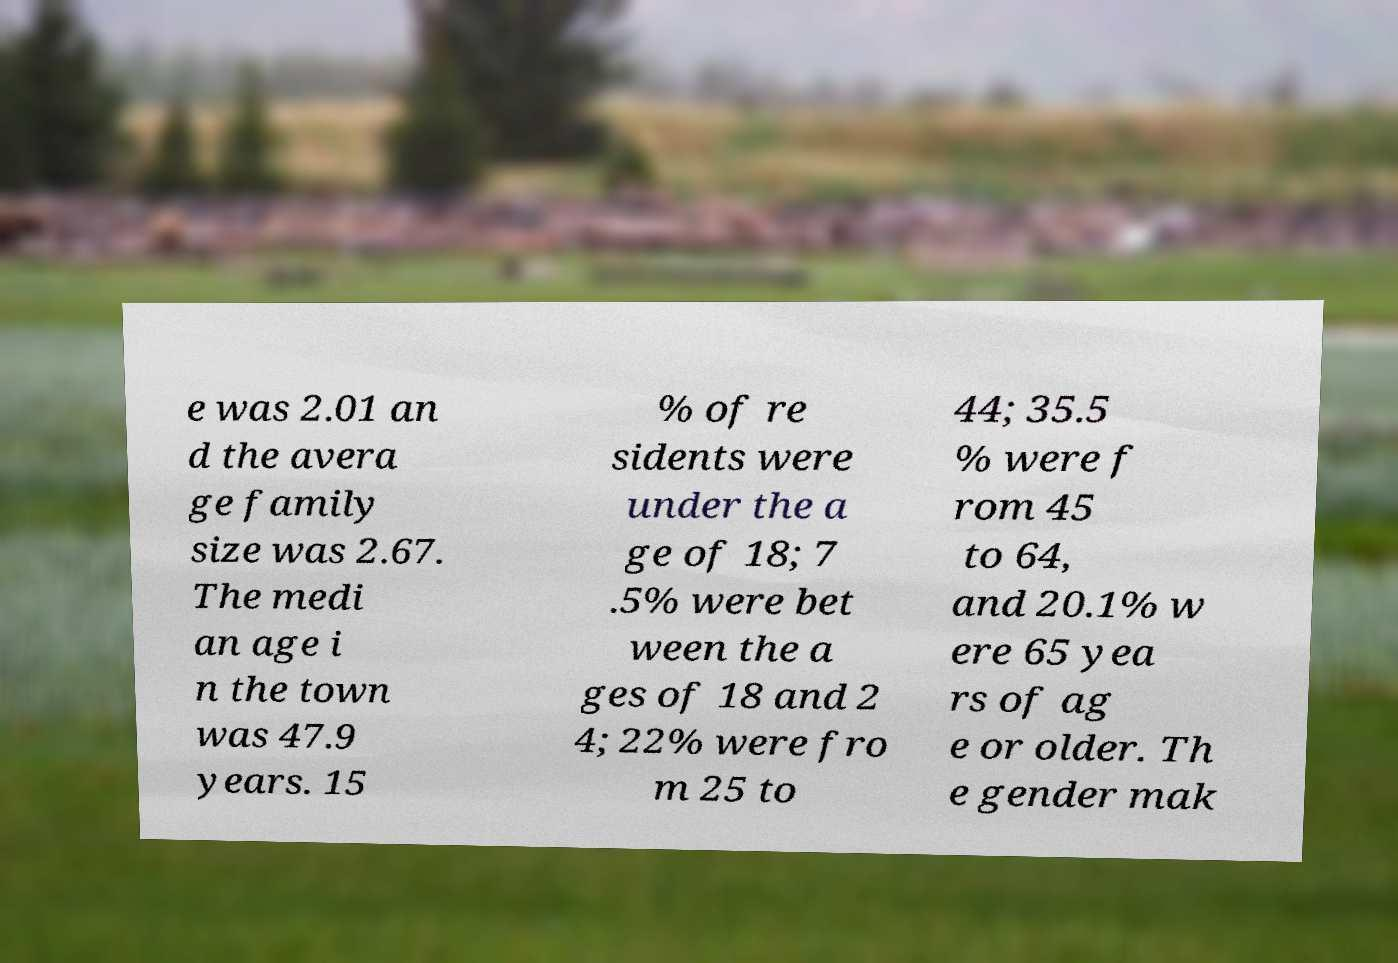What messages or text are displayed in this image? I need them in a readable, typed format. e was 2.01 an d the avera ge family size was 2.67. The medi an age i n the town was 47.9 years. 15 % of re sidents were under the a ge of 18; 7 .5% were bet ween the a ges of 18 and 2 4; 22% were fro m 25 to 44; 35.5 % were f rom 45 to 64, and 20.1% w ere 65 yea rs of ag e or older. Th e gender mak 